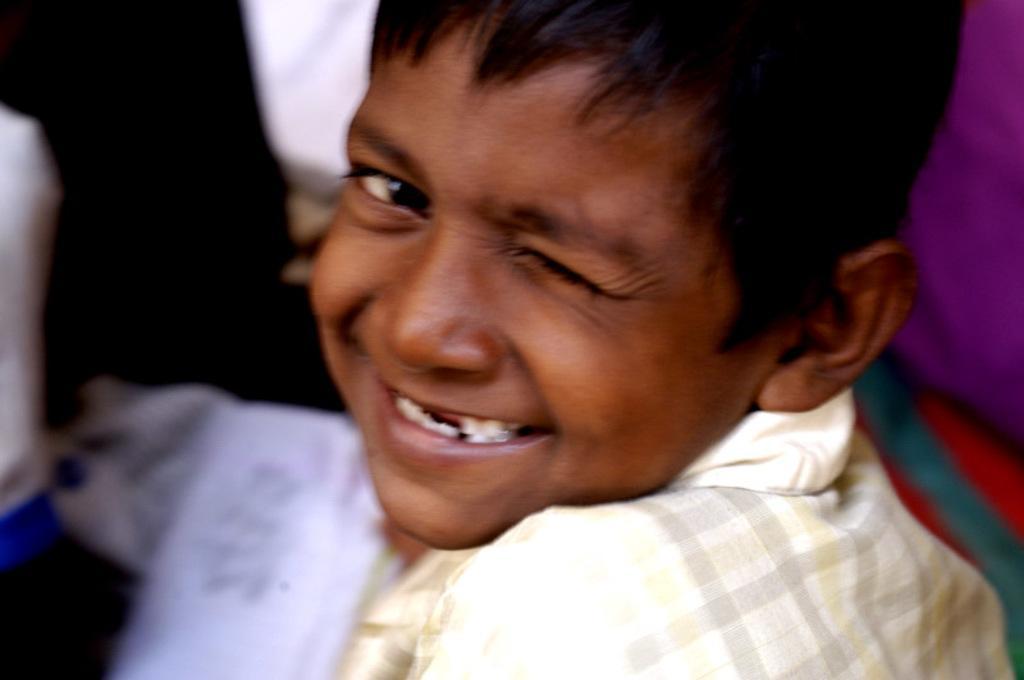Describe this image in one or two sentences. In this image there is a boy who is closing one of his eyes and smiling. Beside him there are few other persons who are not clearly visible. 